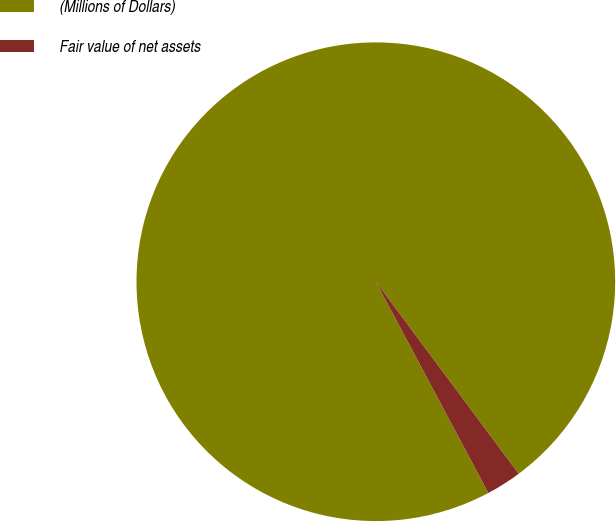Convert chart. <chart><loc_0><loc_0><loc_500><loc_500><pie_chart><fcel>(Millions of Dollars)<fcel>Fair value of net assets<nl><fcel>97.61%<fcel>2.39%<nl></chart> 